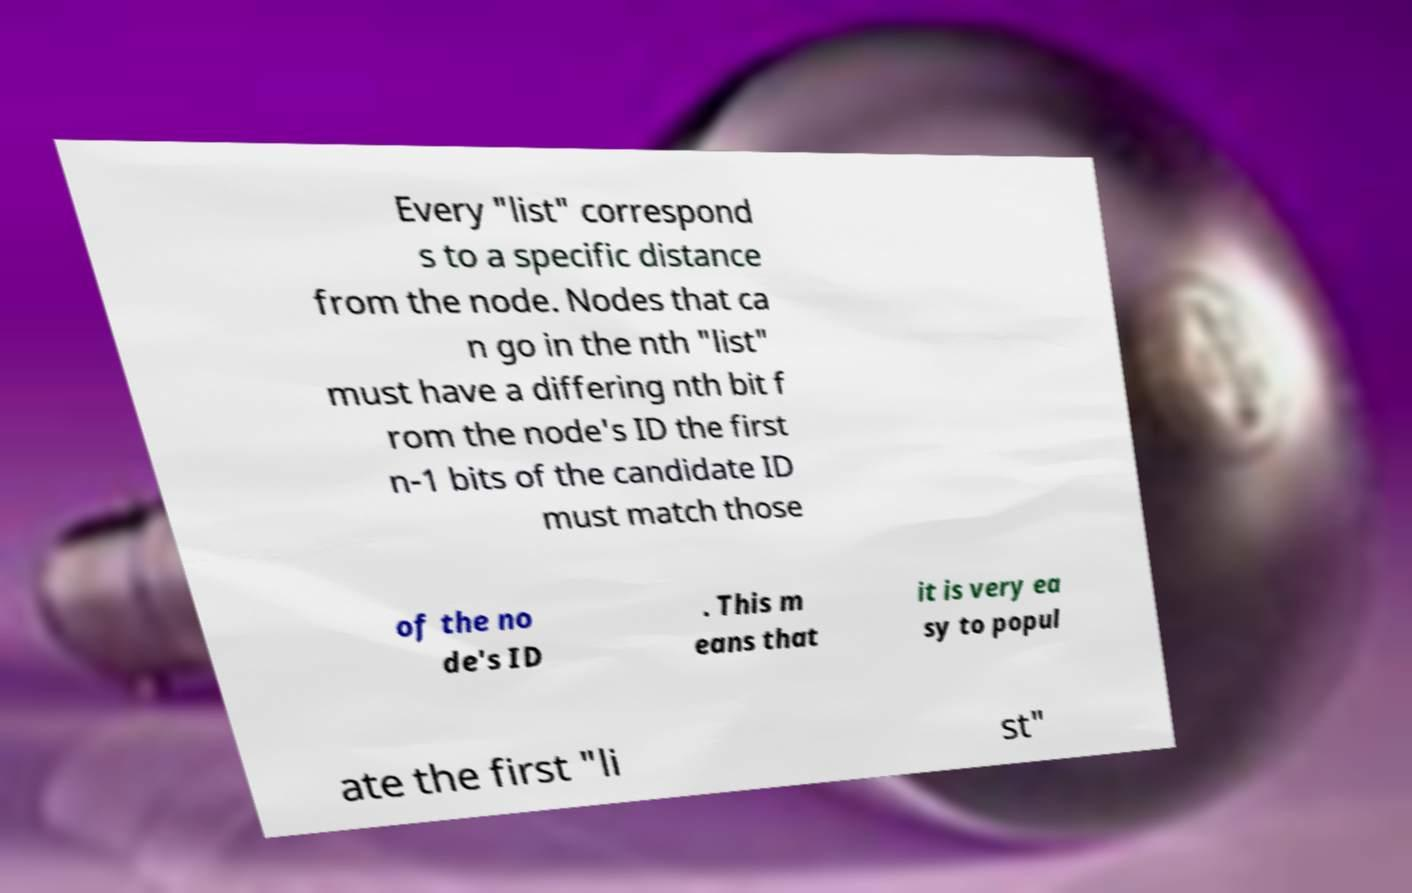Could you extract and type out the text from this image? Every "list" correspond s to a specific distance from the node. Nodes that ca n go in the nth "list" must have a differing nth bit f rom the node's ID the first n-1 bits of the candidate ID must match those of the no de's ID . This m eans that it is very ea sy to popul ate the first "li st" 